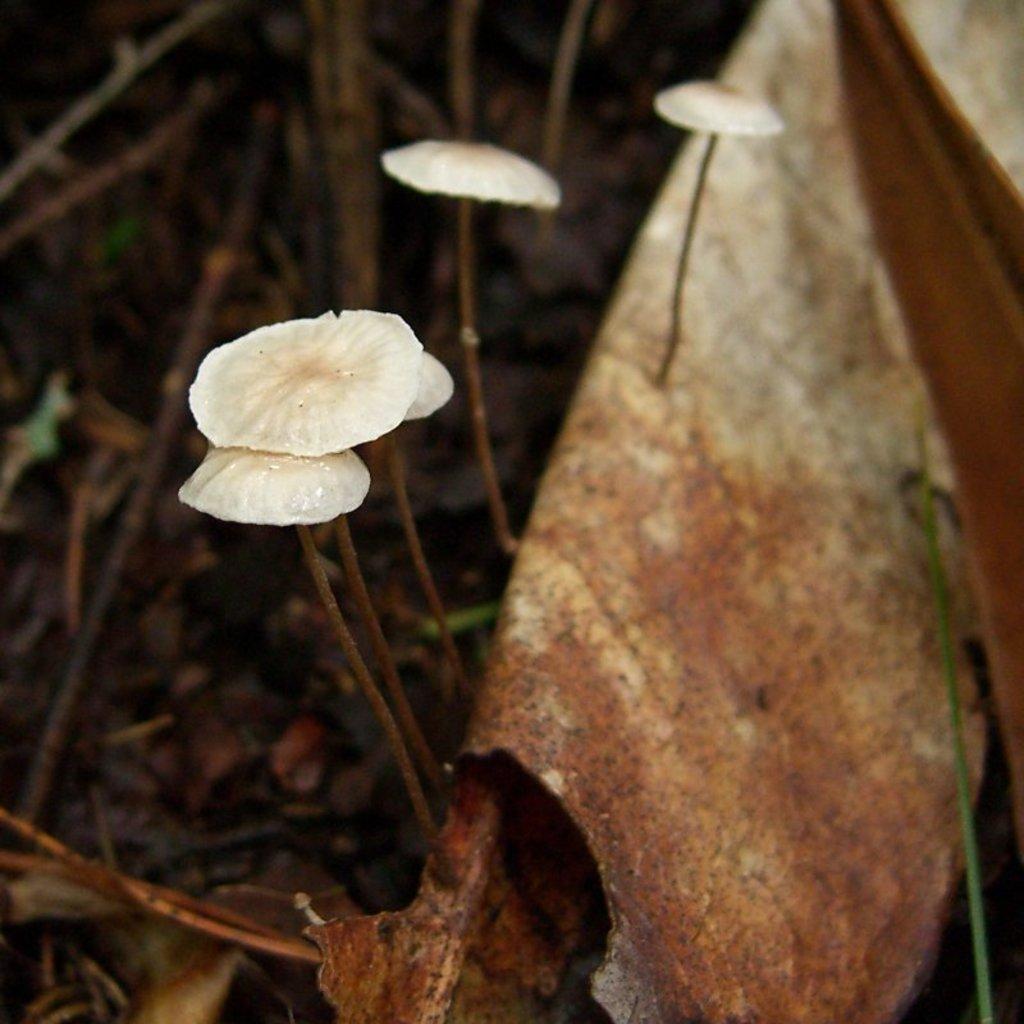How would you summarize this image in a sentence or two? In the foreground of this image, on the right, there is a leaf. In the middle, there are mushrooms and in the background, there are sticks on the ground. 